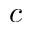<formula> <loc_0><loc_0><loc_500><loc_500>c</formula> 